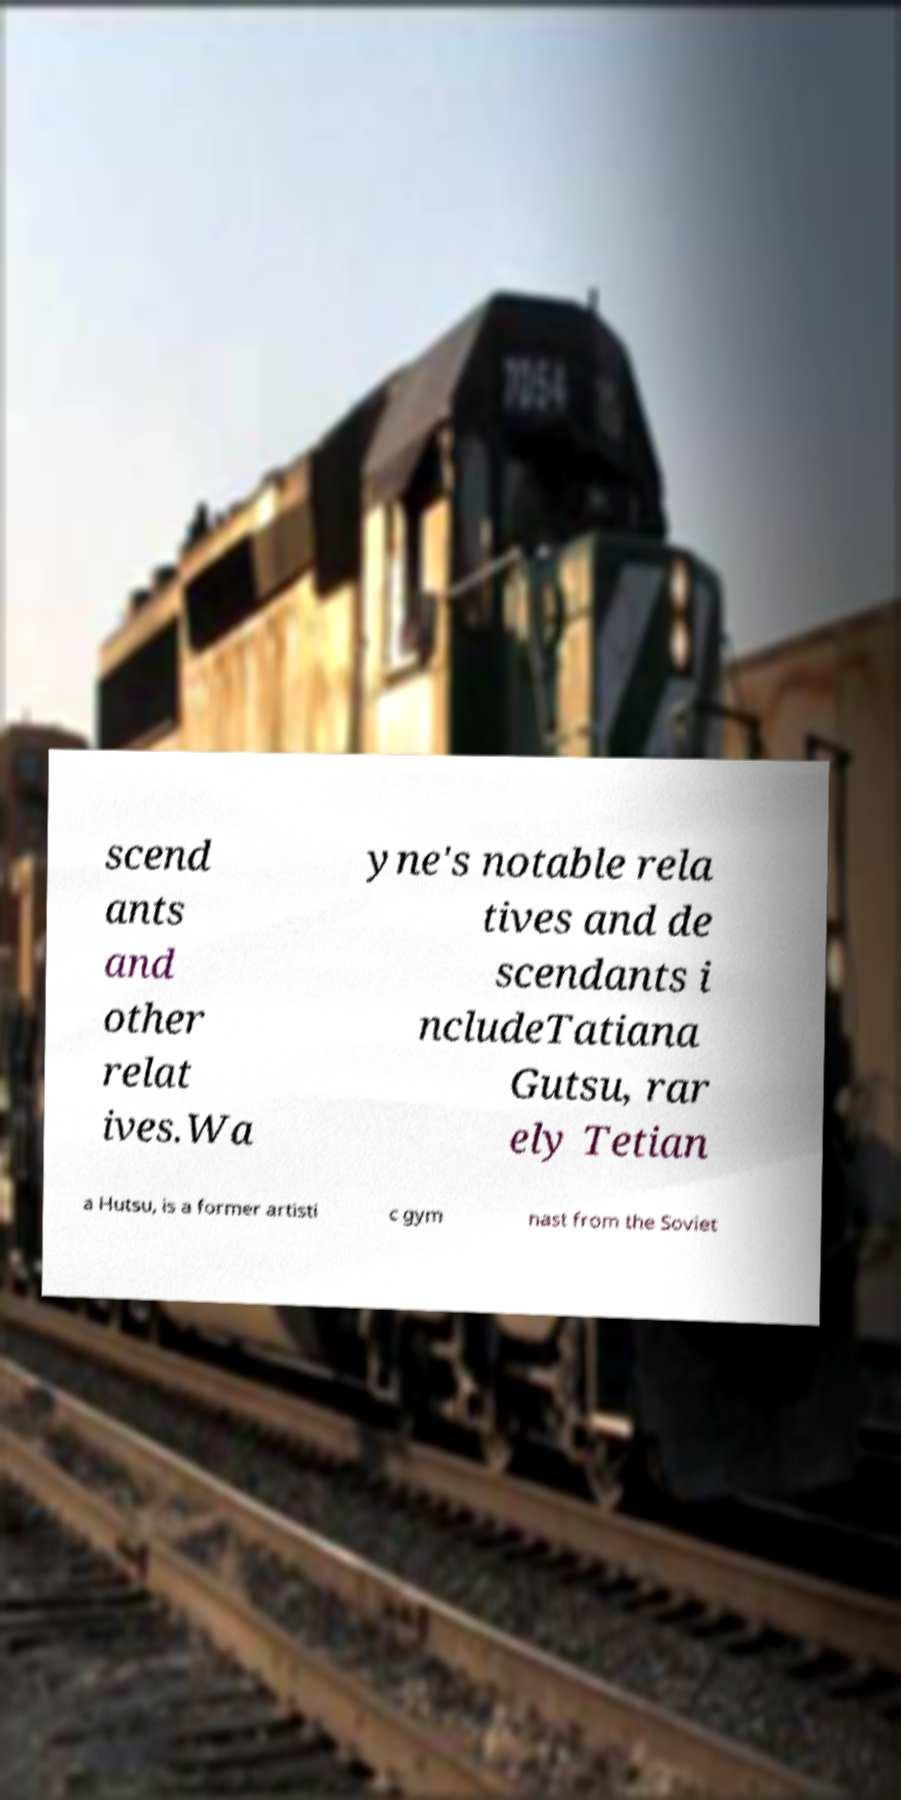What messages or text are displayed in this image? I need them in a readable, typed format. scend ants and other relat ives.Wa yne's notable rela tives and de scendants i ncludeTatiana Gutsu, rar ely Tetian a Hutsu, is a former artisti c gym nast from the Soviet 